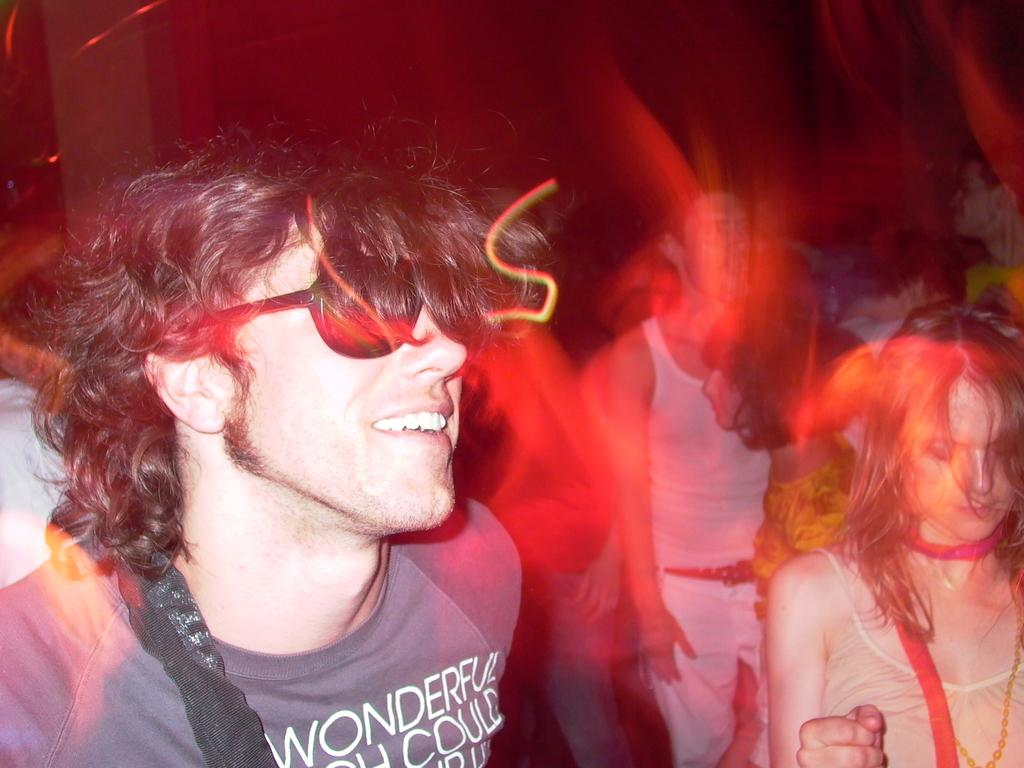How many people are in the image? The number of people in the image cannot be determined from the given fact. What type of vegetable is being held by the ghost in the image? There is no mention of a ghost or a vegetable in the given fact. 